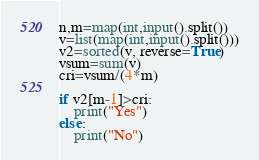Convert code to text. <code><loc_0><loc_0><loc_500><loc_500><_Python_>n,m=map(int,input().split())
v=list(map(int,input().split()))
v2=sorted(v, reverse=True)
vsum=sum(v)
cri=vsum/(4*m)

if v2[m-1]>cri:
    print("Yes")
else:
    print("No")</code> 